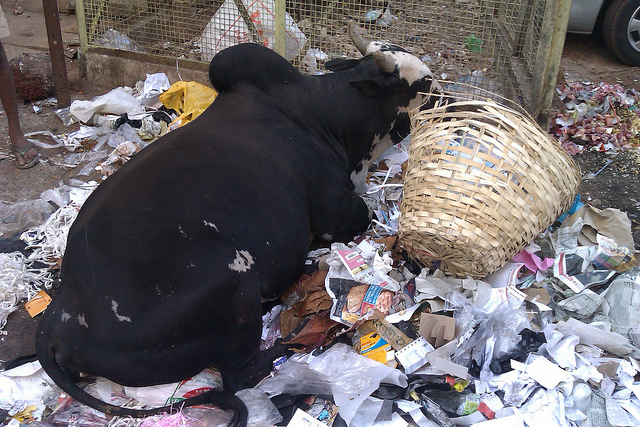<image>Is this animal underweight? I cannot determine if the animal is underweight. Is this animal underweight? It is not clear if the animal is underweight or not. 